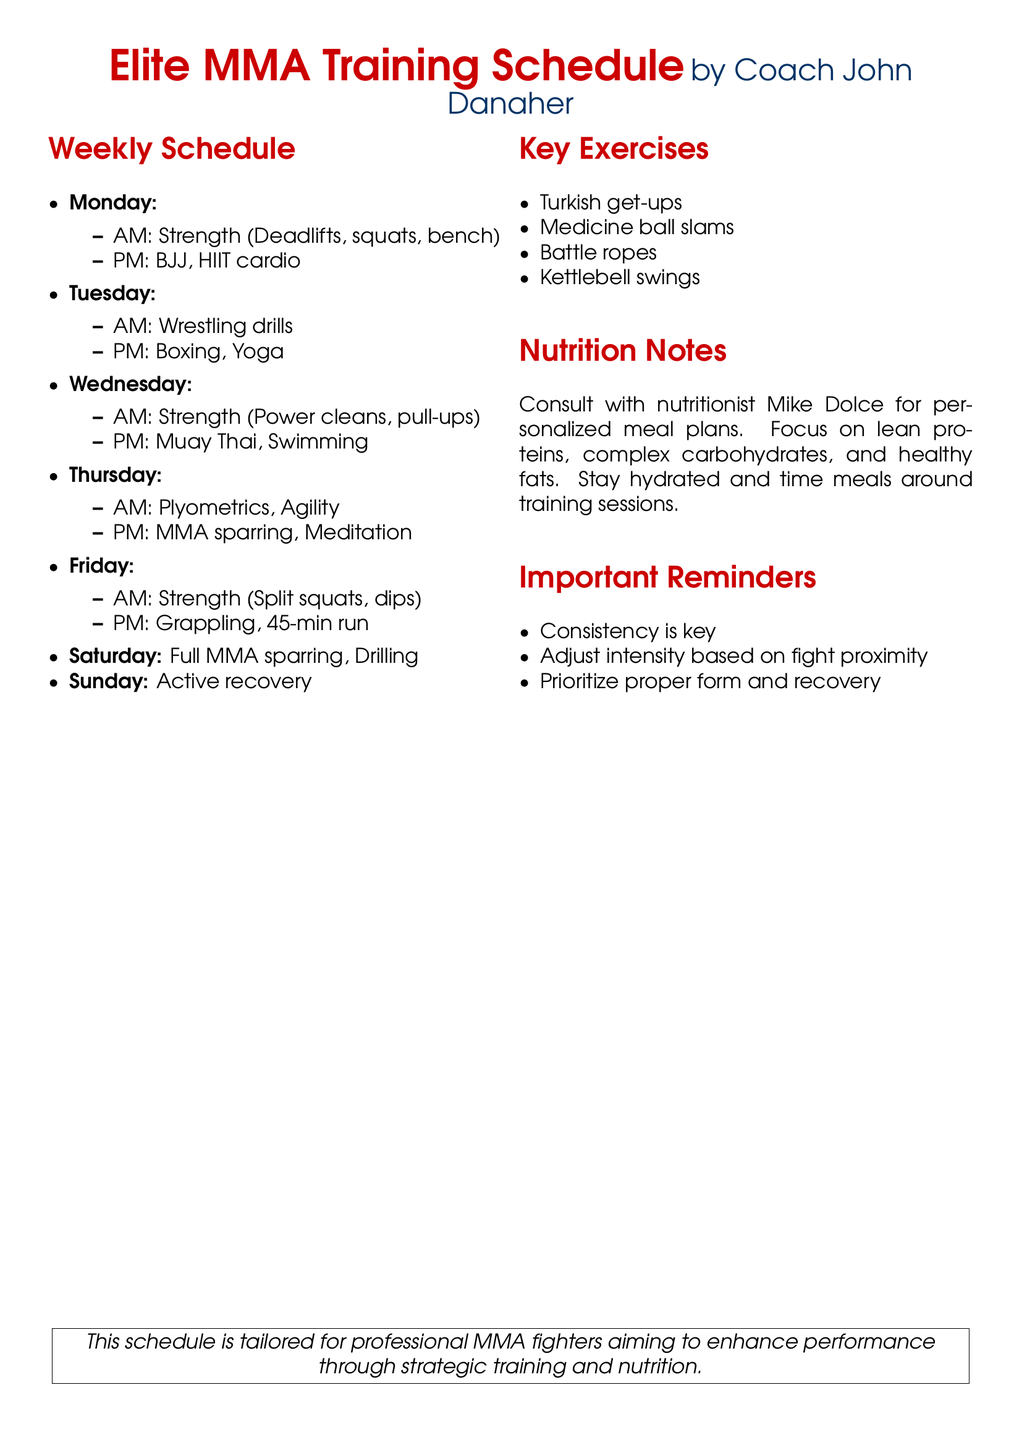What is the name of the coach? The document specifies that the training schedule is provided by Coach John Danaher.
Answer: Coach John Danaher What are the strength exercises on Monday? The AM session on Monday includes Deadlifts, squats, and bench as the strength exercises.
Answer: Deadlifts, squats, bench Which day includes wrestling drills? The document mentions wrestling drills taking place on Tuesday during the AM session.
Answer: Tuesday What is one of the key exercises listed? The document lists several key exercises; one example is Turkish get-ups.
Answer: Turkish get-ups How often is active recovery scheduled? The document states that active recovery is scheduled once a week, specifically on Sunday.
Answer: Once a week What nutritionist is recommended for meal plans? The document suggests consulting nutritionist Mike Dolce for personalized meal plans.
Answer: Mike Dolce What type of training is done on Saturday? The document indicates that Saturday is reserved for full MMA sparring and drilling.
Answer: Full MMA sparring, Drilling What is emphasized in the important reminders? The document highlights that consistency is key among other reminders for training.
Answer: Consistency is key What type of training is included in the PM session on Wednesday? The PM session on Wednesday includes Muay Thai and Swimming activities.
Answer: Muay Thai, Swimming 